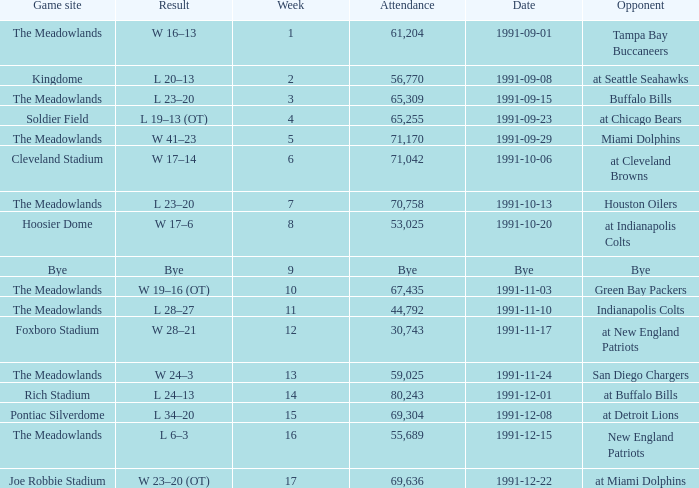What was the Result of the Game at the Meadowlands on 1991-09-01? W 16–13. 